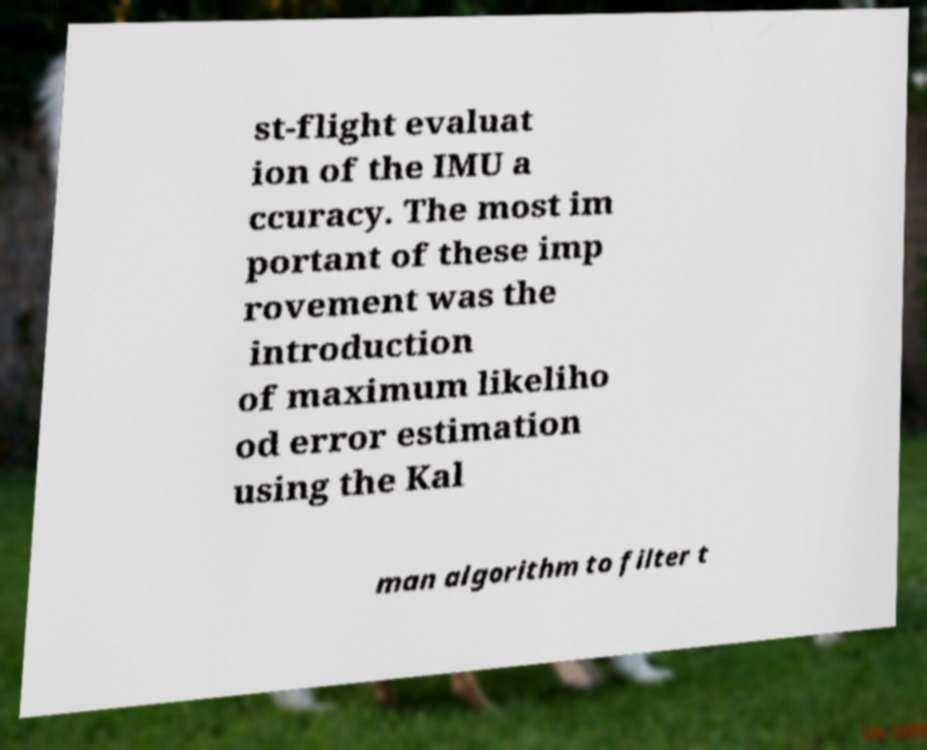Please read and relay the text visible in this image. What does it say? st-flight evaluat ion of the IMU a ccuracy. The most im portant of these imp rovement was the introduction of maximum likeliho od error estimation using the Kal man algorithm to filter t 